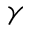<formula> <loc_0><loc_0><loc_500><loc_500>\gamma</formula> 